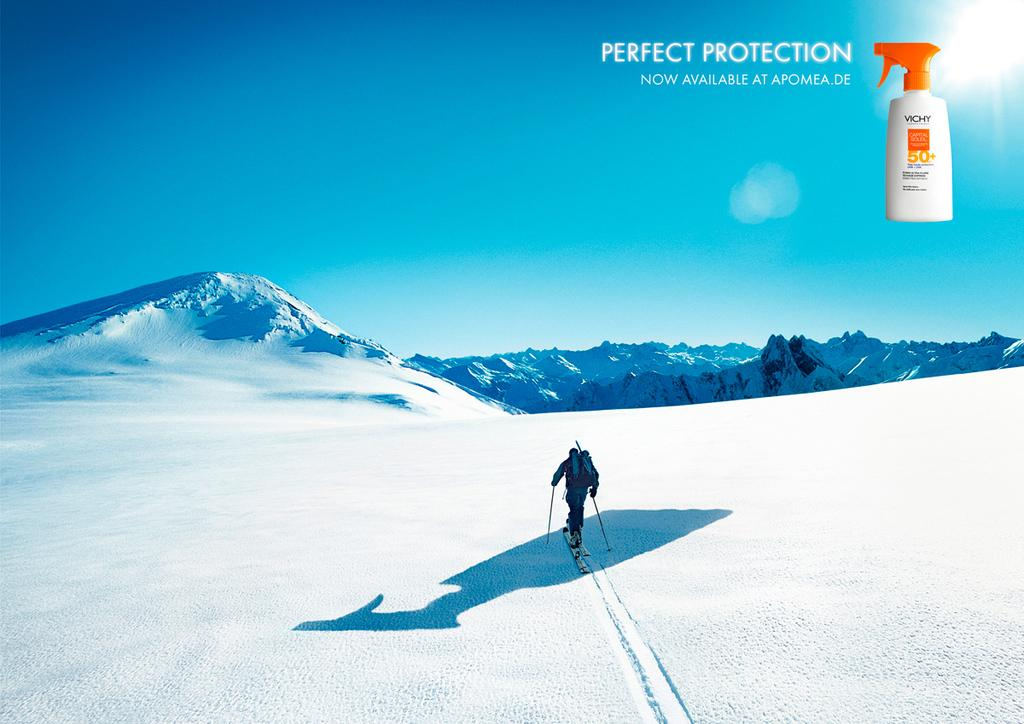<image>
Share a concise interpretation of the image provided. A skier is going up a slope and the word perfect is above him. 